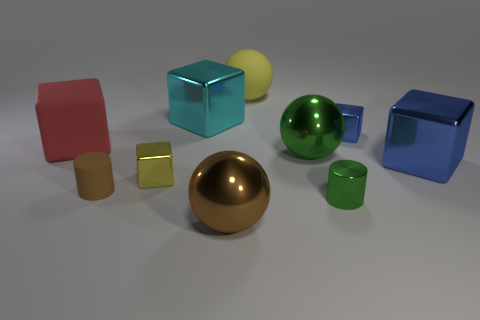How big is the yellow rubber sphere?
Your answer should be compact. Large. How many matte objects are either big purple cylinders or large brown spheres?
Keep it short and to the point. 0. Are there fewer green cylinders than small metallic things?
Your answer should be very brief. Yes. How many other things are the same material as the green sphere?
Your answer should be compact. 6. There is a cyan metal object that is the same shape as the red rubber thing; what is its size?
Give a very brief answer. Large. Does the cylinder that is on the left side of the big cyan cube have the same material as the small cube that is left of the yellow ball?
Give a very brief answer. No. Are there fewer tiny blocks that are in front of the big red rubber block than big green objects?
Your response must be concise. No. Is there anything else that has the same shape as the red thing?
Keep it short and to the point. Yes. The other large metallic thing that is the same shape as the big cyan metal object is what color?
Give a very brief answer. Blue. There is a object that is in front of the metallic cylinder; is its size the same as the yellow metal block?
Offer a very short reply. No. 